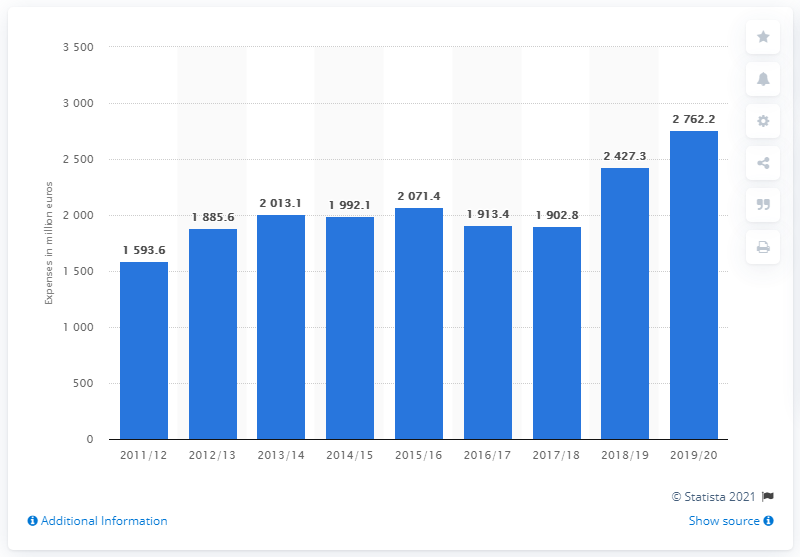Highlight a few significant elements in this photo. In the 2019/2020 financial year, Ryanair spent 27,622.2 million euros on fuel and oil expenses. 